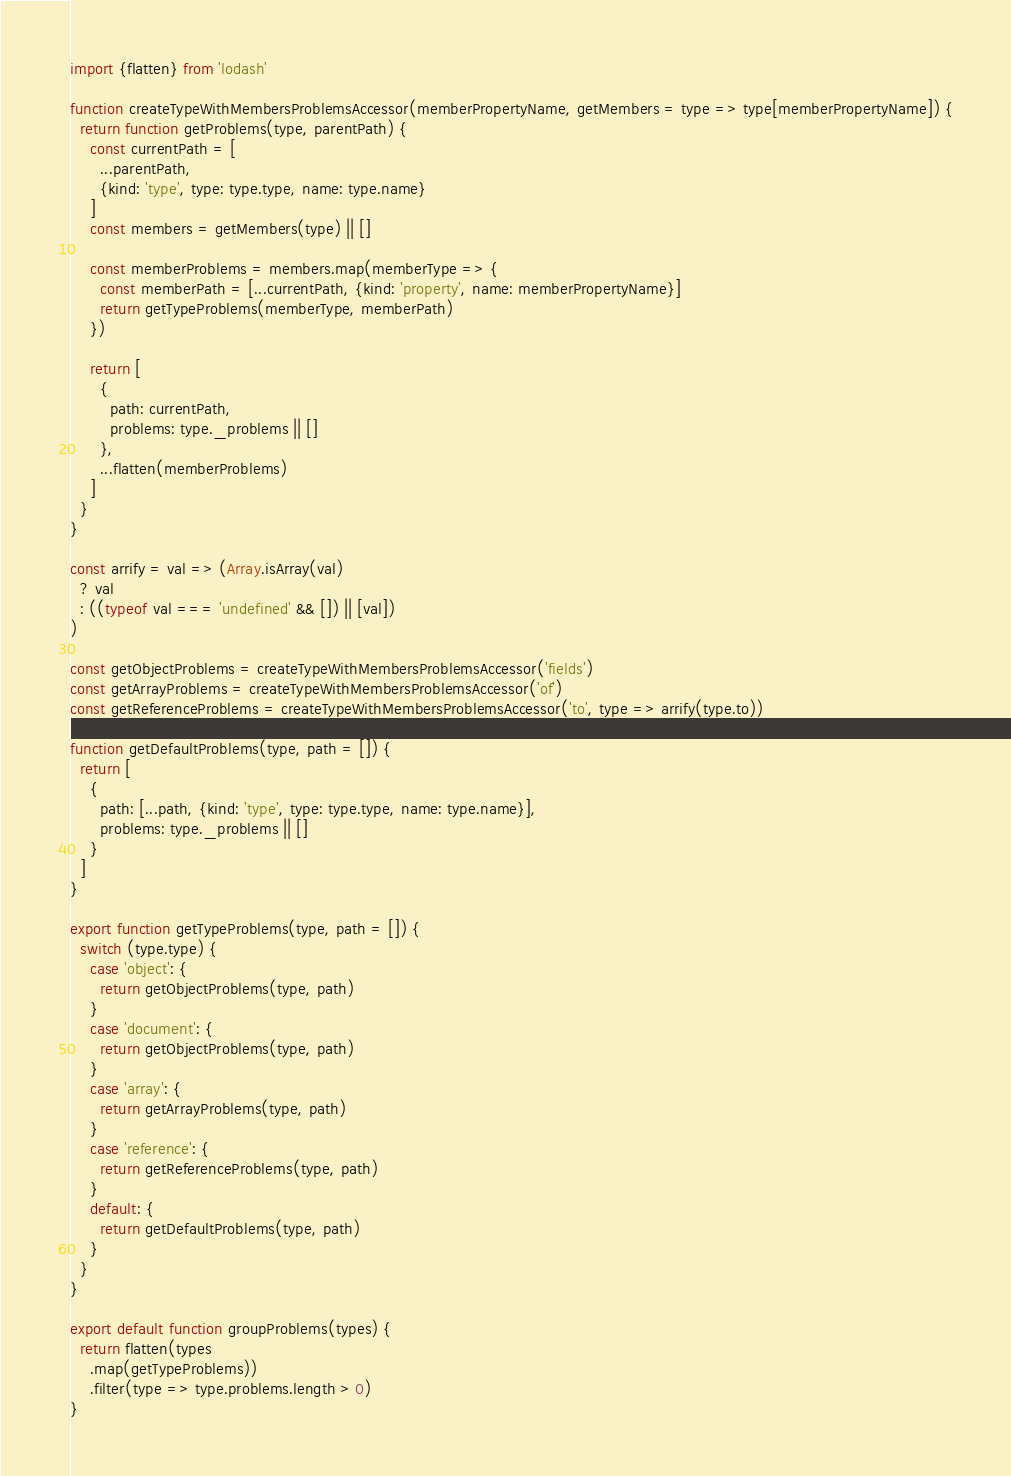<code> <loc_0><loc_0><loc_500><loc_500><_JavaScript_>import {flatten} from 'lodash'

function createTypeWithMembersProblemsAccessor(memberPropertyName, getMembers = type => type[memberPropertyName]) {
  return function getProblems(type, parentPath) {
    const currentPath = [
      ...parentPath,
      {kind: 'type', type: type.type, name: type.name}
    ]
    const members = getMembers(type) || []

    const memberProblems = members.map(memberType => {
      const memberPath = [...currentPath, {kind: 'property', name: memberPropertyName}]
      return getTypeProblems(memberType, memberPath)
    })

    return [
      {
        path: currentPath,
        problems: type._problems || []
      },
      ...flatten(memberProblems)
    ]
  }
}

const arrify = val => (Array.isArray(val)
  ? val
  : ((typeof val === 'undefined' && []) || [val])
)

const getObjectProblems = createTypeWithMembersProblemsAccessor('fields')
const getArrayProblems = createTypeWithMembersProblemsAccessor('of')
const getReferenceProblems = createTypeWithMembersProblemsAccessor('to', type => arrify(type.to))

function getDefaultProblems(type, path = []) {
  return [
    {
      path: [...path, {kind: 'type', type: type.type, name: type.name}],
      problems: type._problems || []
    }
  ]
}

export function getTypeProblems(type, path = []) {
  switch (type.type) {
    case 'object': {
      return getObjectProblems(type, path)
    }
    case 'document': {
      return getObjectProblems(type, path)
    }
    case 'array': {
      return getArrayProblems(type, path)
    }
    case 'reference': {
      return getReferenceProblems(type, path)
    }
    default: {
      return getDefaultProblems(type, path)
    }
  }
}

export default function groupProblems(types) {
  return flatten(types
    .map(getTypeProblems))
    .filter(type => type.problems.length > 0)
}
</code> 